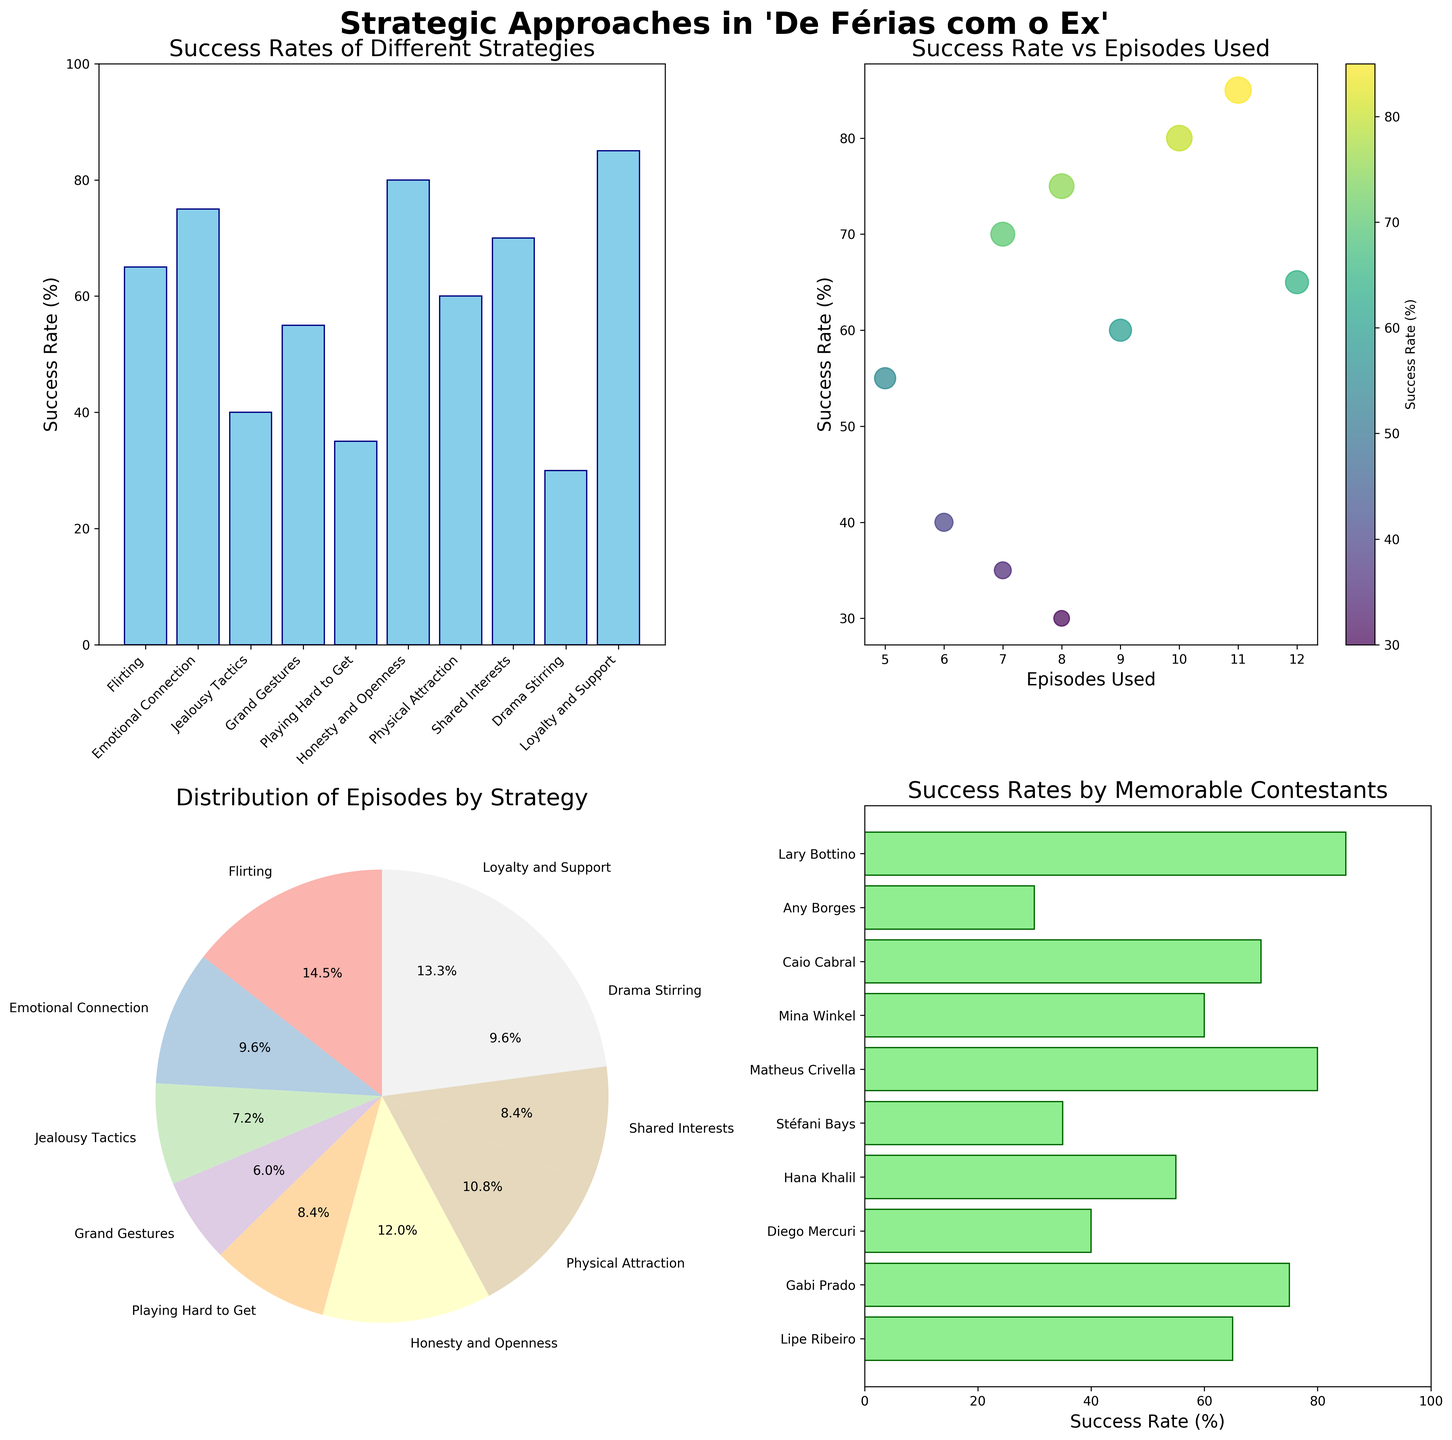What is the success rate of the strategy 'Loyalty and Support'? The 'Loyalty and Support' strategy bar in the bar plot shows a success rate of 85%.
Answer: 85% Which strategy has been used in the most episodes? In the pie chart and bar plot, 'Flirting' is shown to be used in 12 episodes, more than any other strategy.
Answer: Flirting Who is the memorable contestant associated with the highest success rate? In the horizontal bar chart, 'Lary Bottino' associated with 'Loyalty and Support' has the highest success rate of 85%.
Answer: Lary Bottino How many strategies have a success rate of 70% or higher? In the bar plot, 'Emotional Connection' (75%), 'Honesty and Openness' (80%), 'Shared Interests' (70%), and 'Loyalty and Support' (85%) are the strategies with success rates of 70% or higher. That's 4 strategies in total.
Answer: 4 Which strategy has the lowest success rate and what is it? In the bar plot, 'Drama Stirring' has the lowest success rate at 30%.
Answer: Drama Stirring - 30% What is the total number of episodes in which 'Grand Gestures' and 'Playing Hard to Get' have been used? The pie chart and bar plot show that 'Grand Gestures' has been used in 5 episodes and 'Playing Hard to Get' in 7 episodes. The total is 5 + 7 = 12 episodes.
Answer: 12 episodes Which strategy has a higher success rate: 'Physical Attraction' or 'Jealousy Tactics'? In the bar plot, 'Physical Attraction' has a 60% success rate, while 'Jealousy Tactics' has a 40% success rate. 'Physical Attraction' is higher.
Answer: Physical Attraction What does the color distribution in the scatter plot indicate? The scatter plot uses a colormap where colors vary with success rate values, showing that greens and yellows represent higher success rates, while darker colors represent lower success rates.
Answer: Success rates How does the success rate of 'Emotional Connection' compare to the success rate of 'Flirting'? 'Emotional Connection' has a success rate of 75% as seen in the bar plot, while 'Flirting' has a success rate of 65%. 'Emotional Connection' is 10% higher.
Answer: Emotional Connection is higher by 10% What is the average success rate for strategies used in 8 or more episodes? The strategies used in 8 or more episodes are 'Flirting' (65%), 'Emotional Connection' (75%), 'Drama Stirring' (30%), 'Honesty and Openness' (80%), and 'Physical Attraction' (60%). The average is (65 + 75 + 30 + 80 + 60) / 5 = 62%.
Answer: 62% 